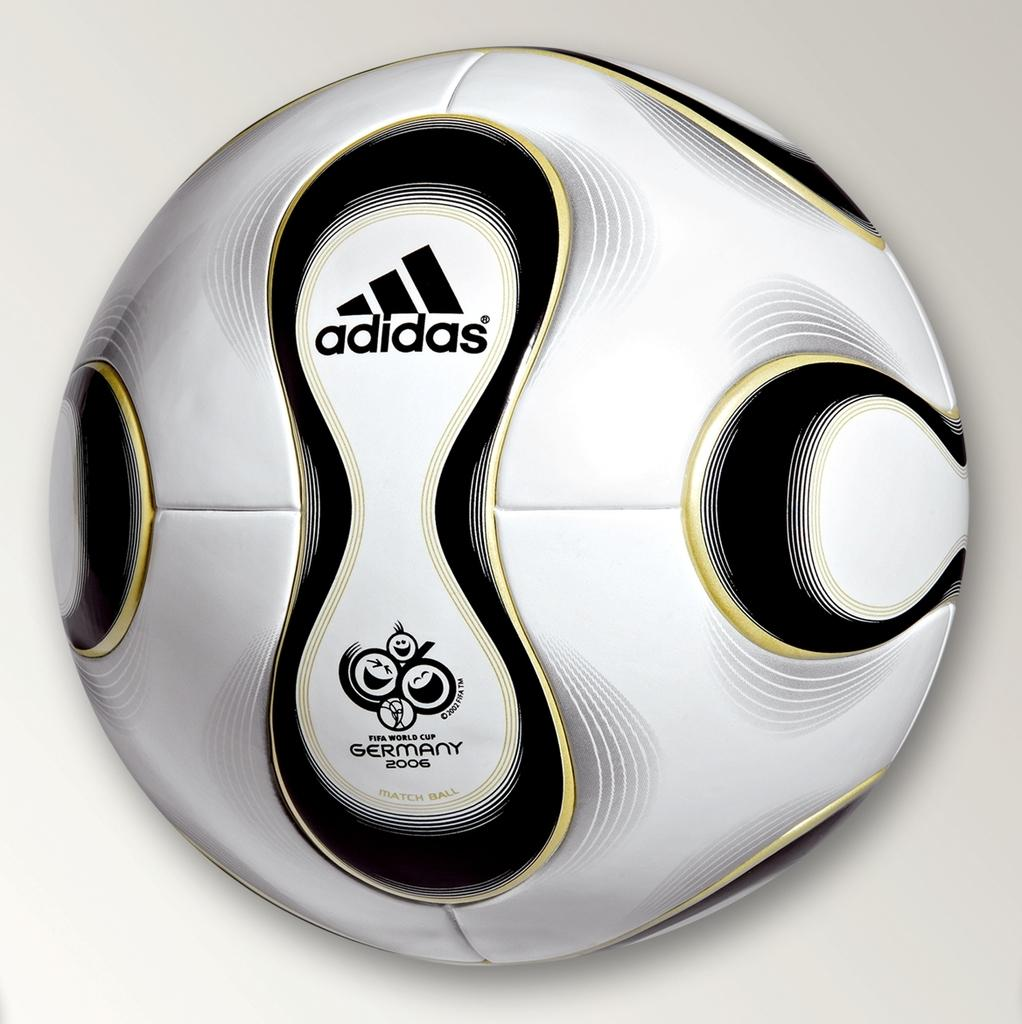What is the color of the ball in the image? The ball in the image is white. What color is the background of the image? The background of the image is white. What type of underwear is hanging on the rail in the image? There is no underwear or rail present in the image. 